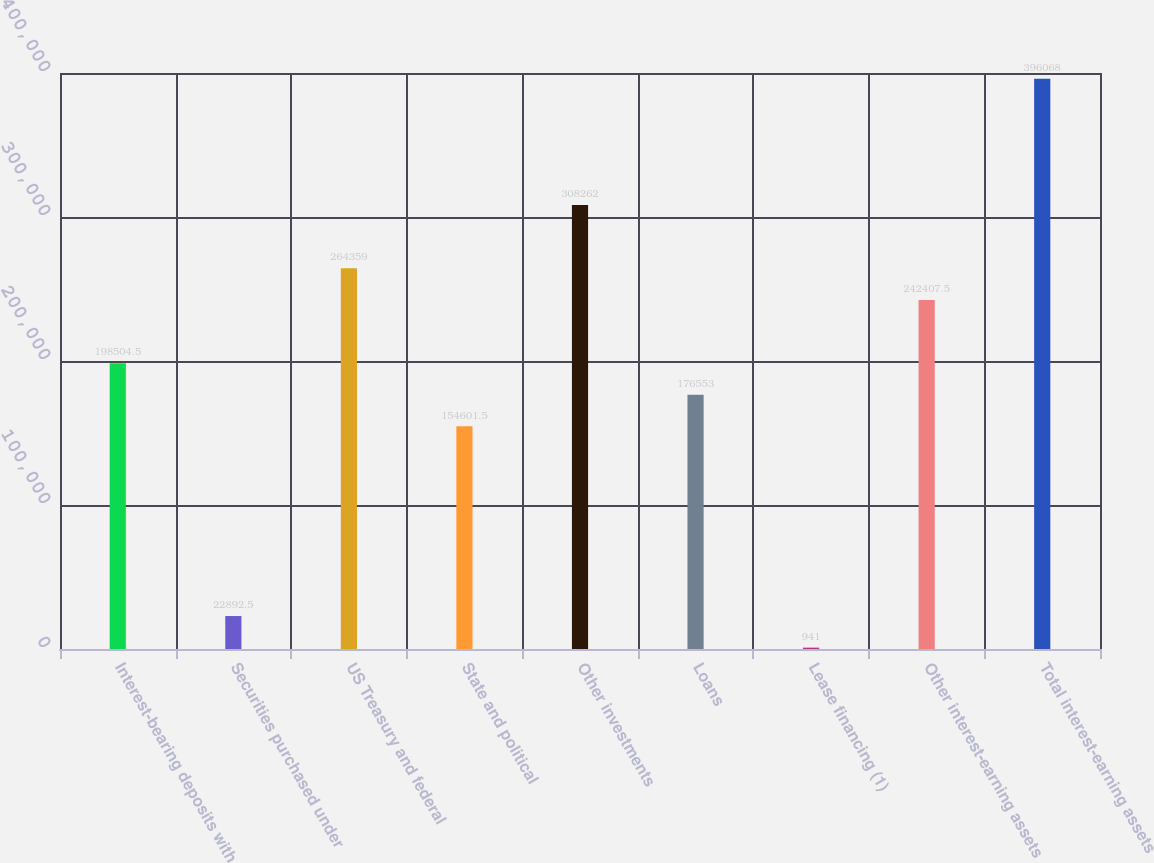Convert chart to OTSL. <chart><loc_0><loc_0><loc_500><loc_500><bar_chart><fcel>Interest-bearing deposits with<fcel>Securities purchased under<fcel>US Treasury and federal<fcel>State and political<fcel>Other investments<fcel>Loans<fcel>Lease financing (1)<fcel>Other interest-earning assets<fcel>Total interest-earning assets<nl><fcel>198504<fcel>22892.5<fcel>264359<fcel>154602<fcel>308262<fcel>176553<fcel>941<fcel>242408<fcel>396068<nl></chart> 